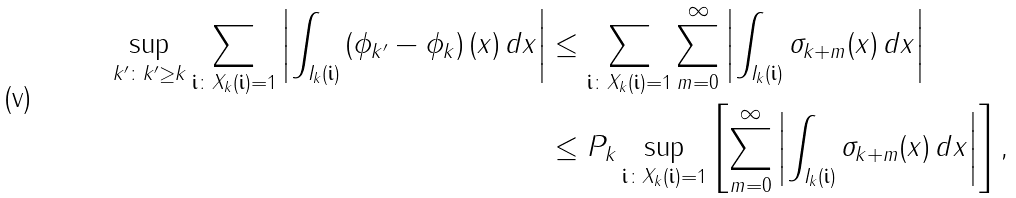Convert formula to latex. <formula><loc_0><loc_0><loc_500><loc_500>\sup _ { k ^ { \prime } \colon k ^ { \prime } \geq k } \sum _ { \begin{subarray} { c } \mathbf i \colon X _ { k } ( \mathbf i ) = 1 \end{subarray} } \left | \int _ { I _ { k } ( \mathbf i ) } \left ( \phi _ { k ^ { \prime } } - \phi _ { k } \right ) ( x ) \, d x \right | & \leq \sum _ { \begin{subarray} { c } \mathbf i \colon X _ { k } ( \mathbf i ) = 1 \end{subarray} } \sum _ { m = 0 } ^ { \infty } \left | \int _ { I _ { k } ( \mathbf i ) } \sigma _ { k + m } ( x ) \, d x \right | \\ & \leq P _ { k } \sup _ { \mathbf i \colon X _ { k } ( \mathbf i ) = 1 } \left [ \sum _ { m = 0 } ^ { \infty } \left | \int _ { I _ { k } ( \mathbf i ) } \sigma _ { k + m } ( x ) \, d x \right | \right ] ,</formula> 